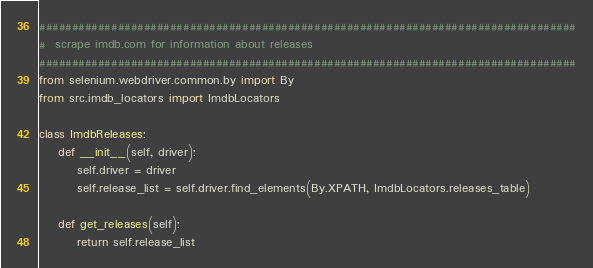<code> <loc_0><loc_0><loc_500><loc_500><_Python_>##################################################################################
#  scrape imdb.com for information about releases
##################################################################################
from selenium.webdriver.common.by import By
from src.imdb_locators import ImdbLocators

class ImdbReleases:
    def __init__(self, driver):
        self.driver = driver 
        self.release_list = self.driver.find_elements(By.XPATH, ImdbLocators.releases_table)

    def get_releases(self):
        return self.release_list</code> 